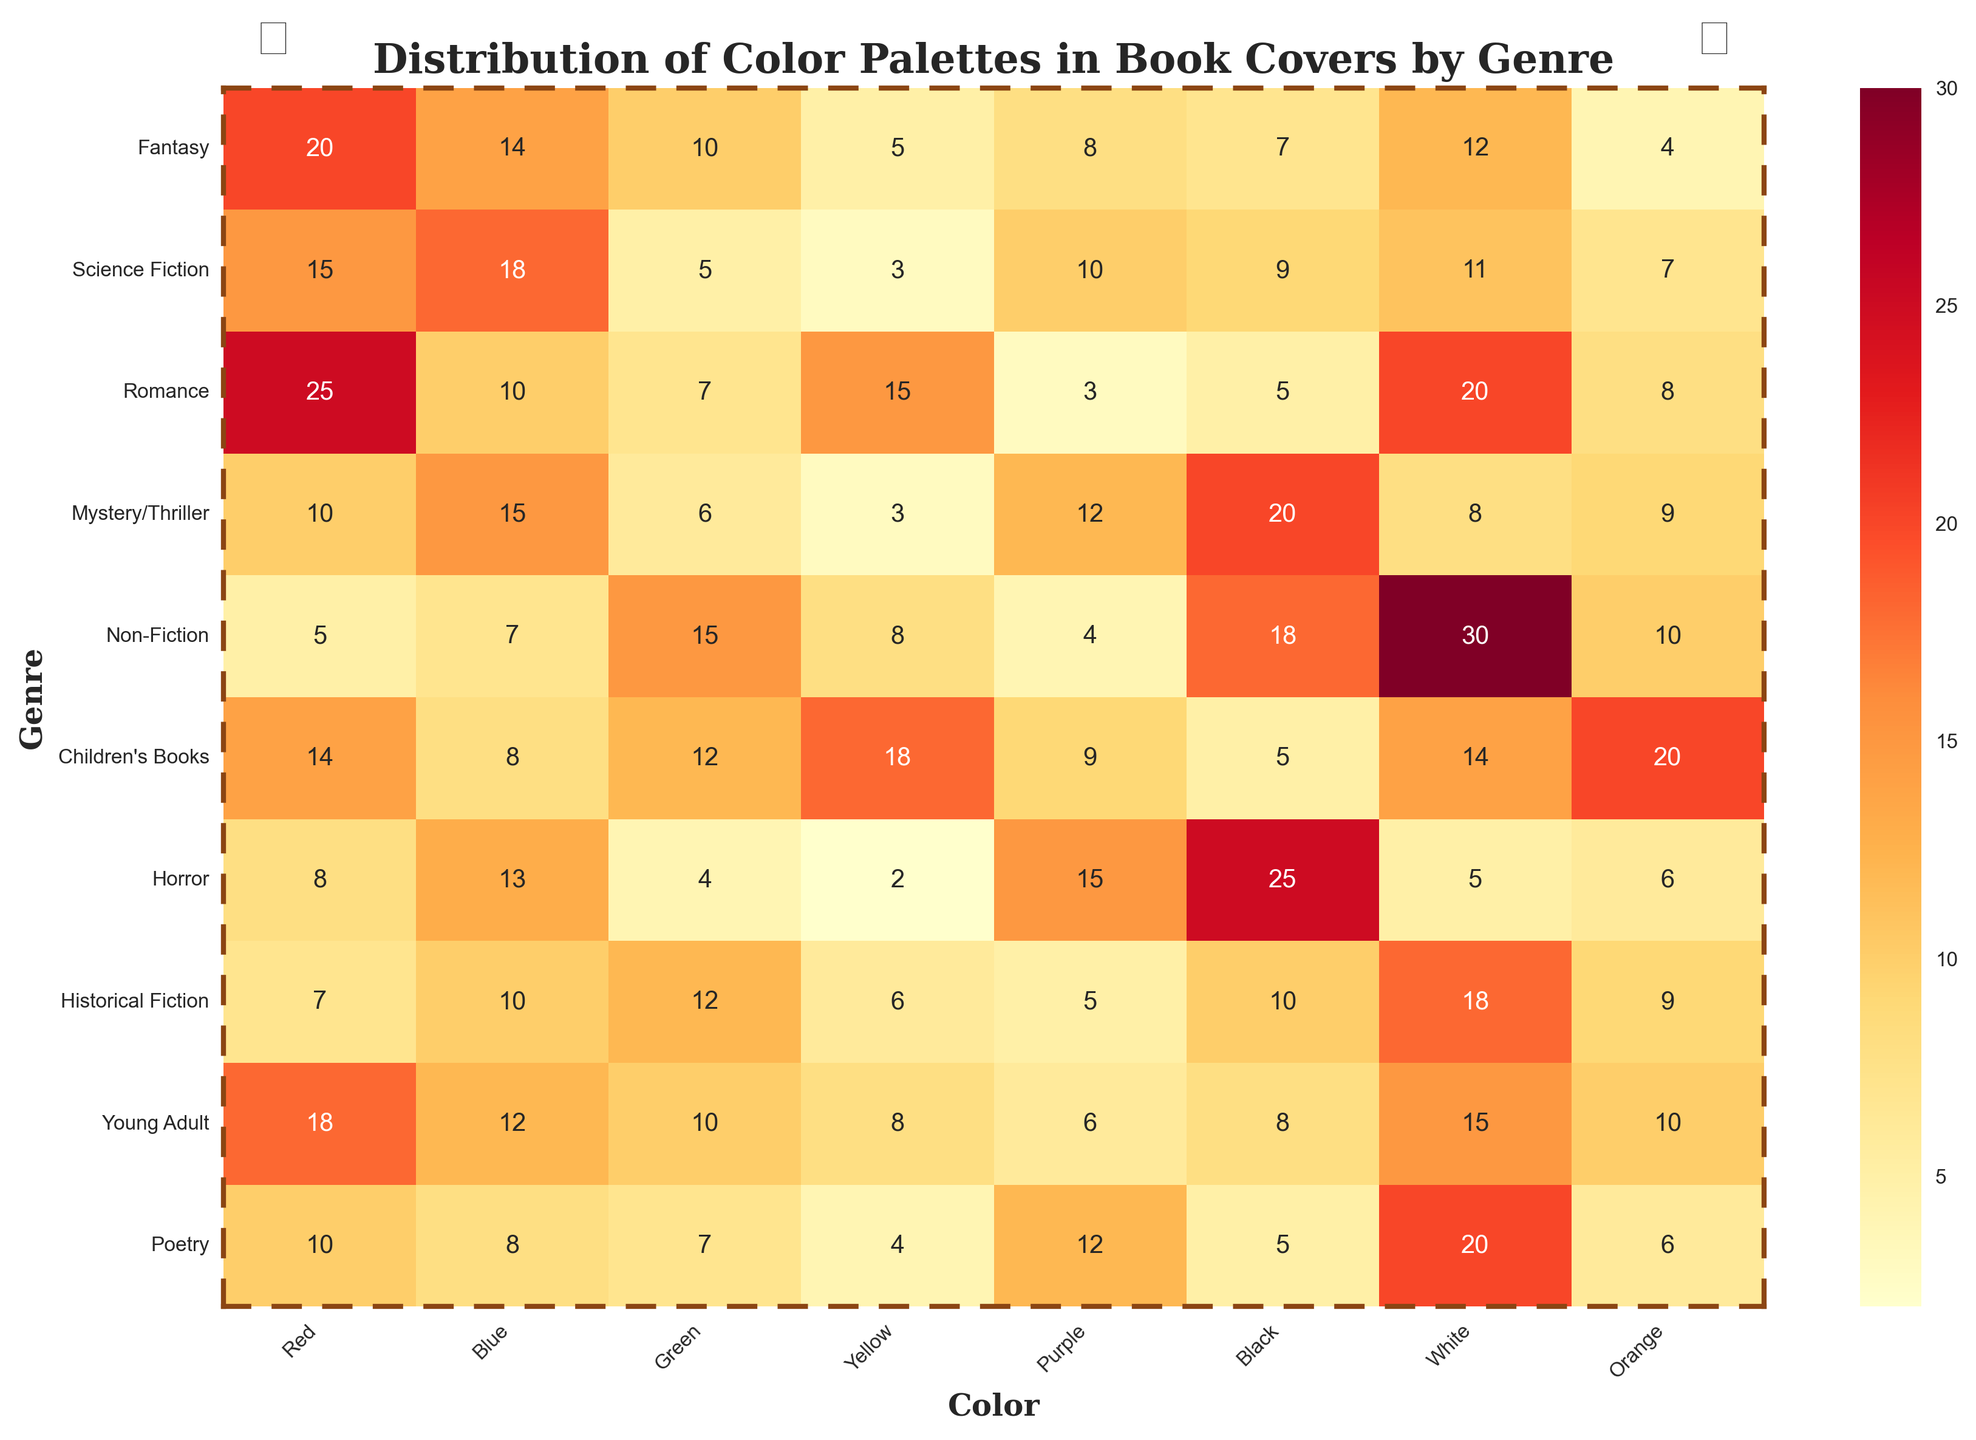What is the most frequently used color in Romance covers? To find this, look at the row for "Romance" and identify the highest number. The numbers for Romance are 25 (Red), 10 (Blue), 7 (Green), 15 (Yellow), 3 (Purple), 5 (Black), 20 (White), and 8 (Orange). The highest number is 25, which is Red.
Answer: Red Which genre uses the most Yellow color? To determine this, look at all the values in the Yellow column and identify the highest number. The numbers are 5, 3, 15, 3, 8, 18, 2, 6, 8, and 4. The highest number is 18, which corresponds to Children’s Books.
Answer: Children's Books How does the use of Black color compare between Mystery/Thriller and Horror genres? Look at the values for Black in the rows for "Mystery/Thriller" and "Horror". Mystery/Thriller has 20 and Horror has 25. Compare these values: 20 is less than 25.
Answer: Horror uses more Black than Mystery/Thriller What is the total usage of Green color across all genres? Sum up the values in the Green column. The numbers are 10, 5, 7, 6, 15, 12, 4, 12, 10, and 7. Adding these gives: 10 + 5 + 7 + 6 + 15 + 12 + 4 + 12 + 10 + 7 = 88.
Answer: 88 Which genre has the least use of Orange color, and what is the count? Look at the values in the Orange column and find the smallest number. The values are 4, 7, 8, 9, 10, 20, 6, 9, 10, and 6. The smallest number is 4, which corresponds to Fantasy.
Answer: Fantasy, 4 Compare the total usage of Red and Blue colors in Non-Fiction. Which one is used more? Look at the values in the Red and Blue columns for the row of Non-Fiction. Red is 5 and Blue is 7. Compare these values: 5 is less than 7.
Answer: Blue is used more than Red in Non-Fiction What is the average use of color White in Fantasy and Science Fiction genres? Look at the values for White in the rows for Fantasy and Science Fiction. Fantasy has 12 and Science Fiction has 11. Calculate the average: (12 + 11) / 2 = 23 / 2 = 11.5.
Answer: 11.5 Which genre uses the Purple color the most? Look at the values for the Purple column and identify the highest number. The numbers are 8, 10, 3, 12, 4, 9, 15, 5, 6, and 12. The highest number is 15, which corresponds to Horror.
Answer: Horror How does the total use of primary colors (Red, Blue, Green) compare between Young Adult and Poetry genres? Sum the values for Red, Blue, and Green for both genres. Young Adult: 18 (Red) + 12 (Blue) + 10 (Green) = 40. Poetry: 10 (Red) + 8 (Blue) + 7 (Green) = 25. Compare these sums: 40 is greater than 25.
Answer: Young Adult uses more primary colors than Poetry In which genre is the use of Red approximately double the use of Green? Look for genres where the value for Red is around twice the value for Green. Fantasy has 20 (Red) and 10 (Green).
Answer: Fantasy 